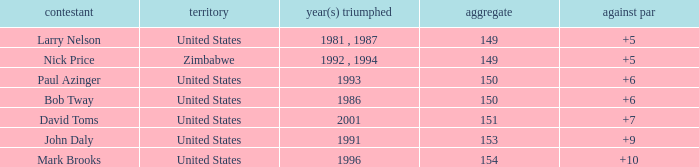What is Zimbabwe's total with a to par higher than 5? None. 